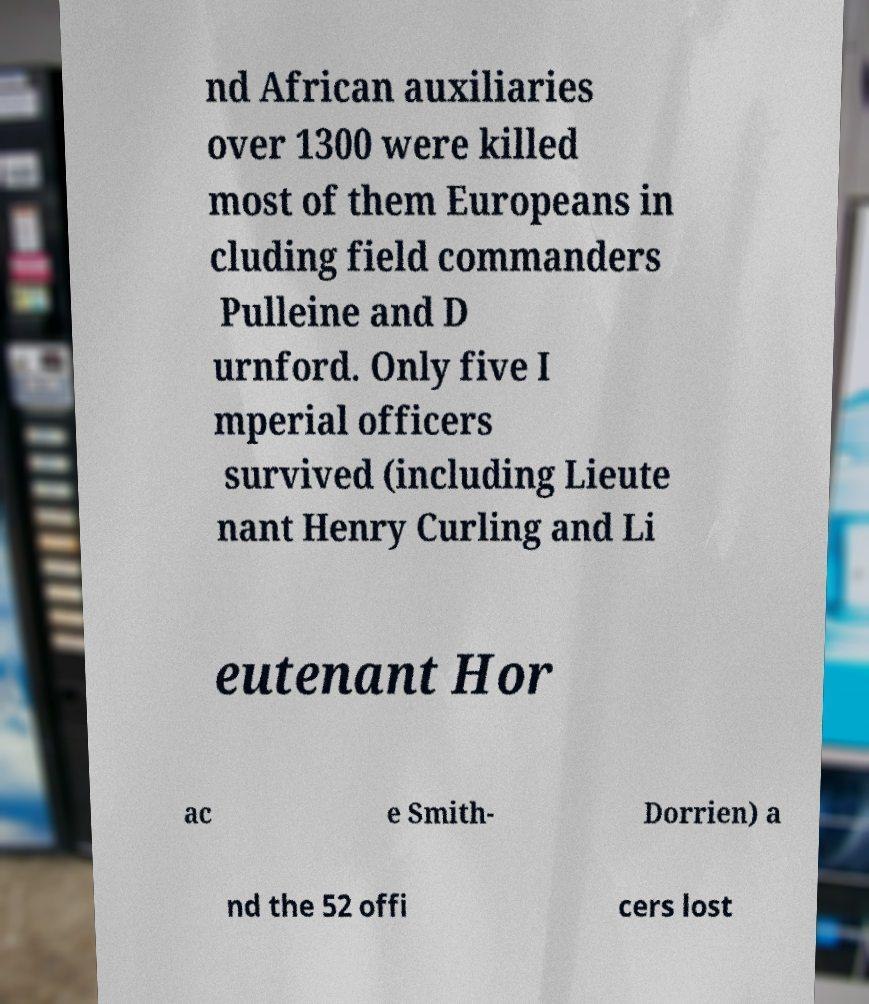Could you extract and type out the text from this image? nd African auxiliaries over 1300 were killed most of them Europeans in cluding field commanders Pulleine and D urnford. Only five I mperial officers survived (including Lieute nant Henry Curling and Li eutenant Hor ac e Smith- Dorrien) a nd the 52 offi cers lost 